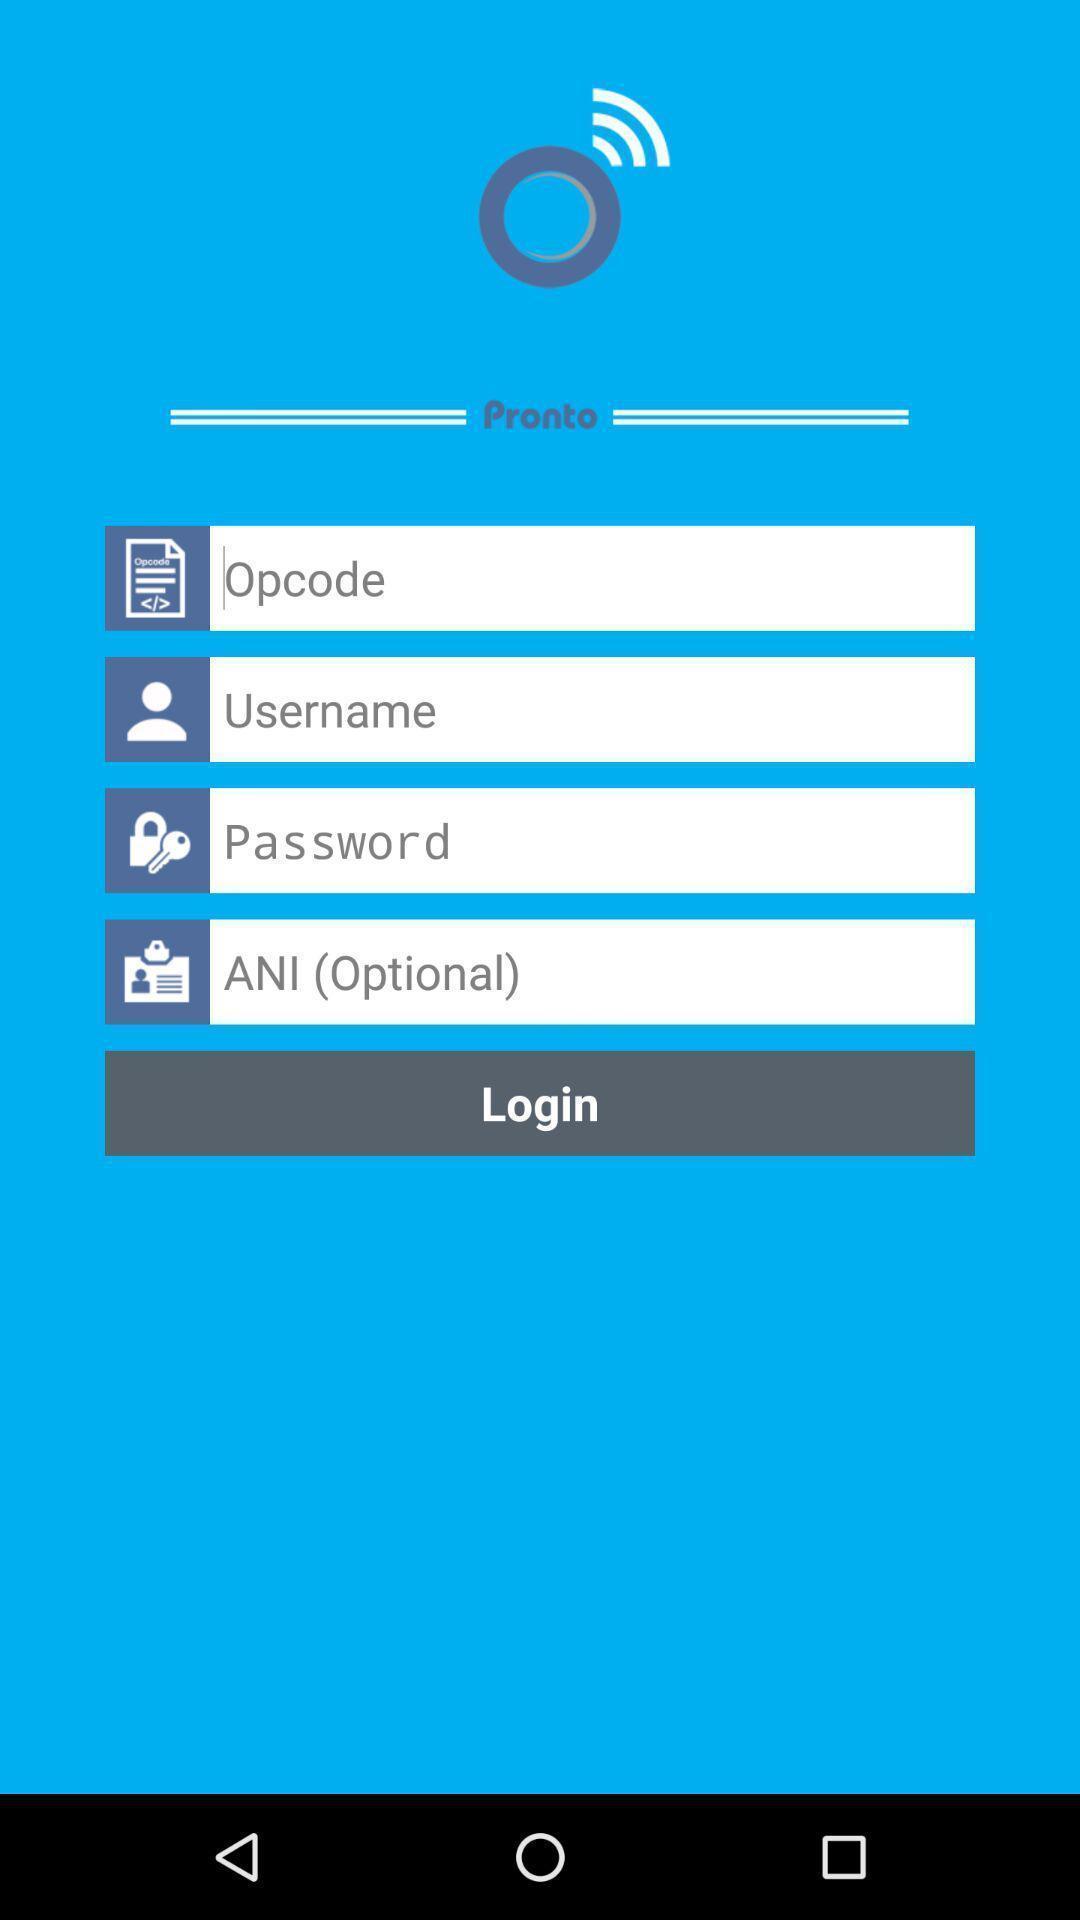What details can you identify in this image? Screen displaying the input field for login into app. 